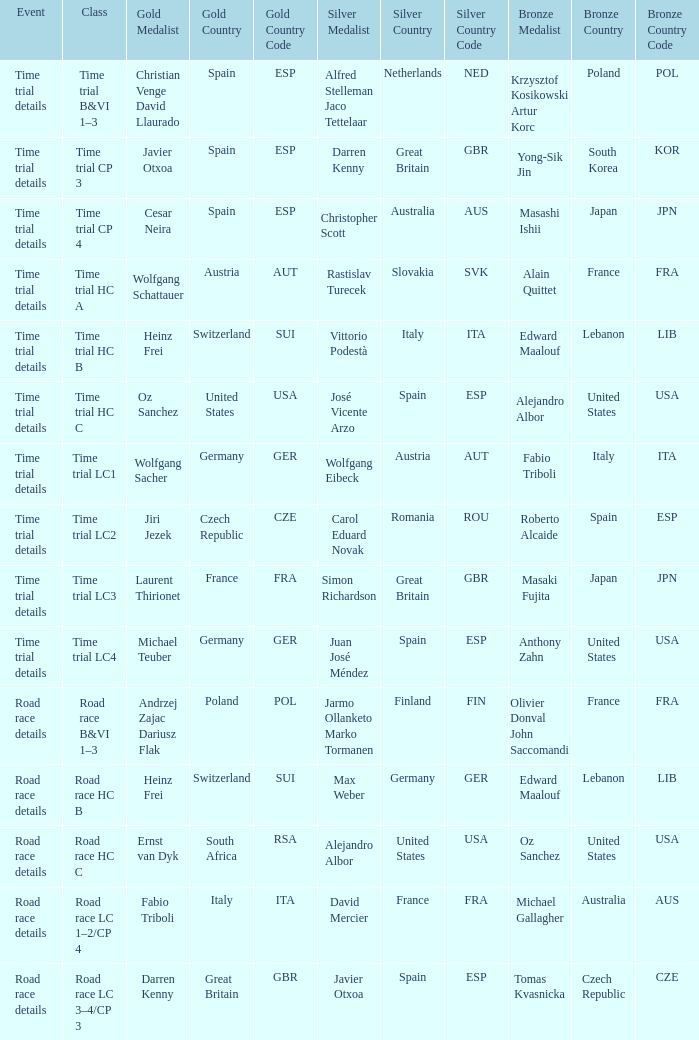What is the happening when gold is won by darren kenny of great britain (gbr)? Road race details. 